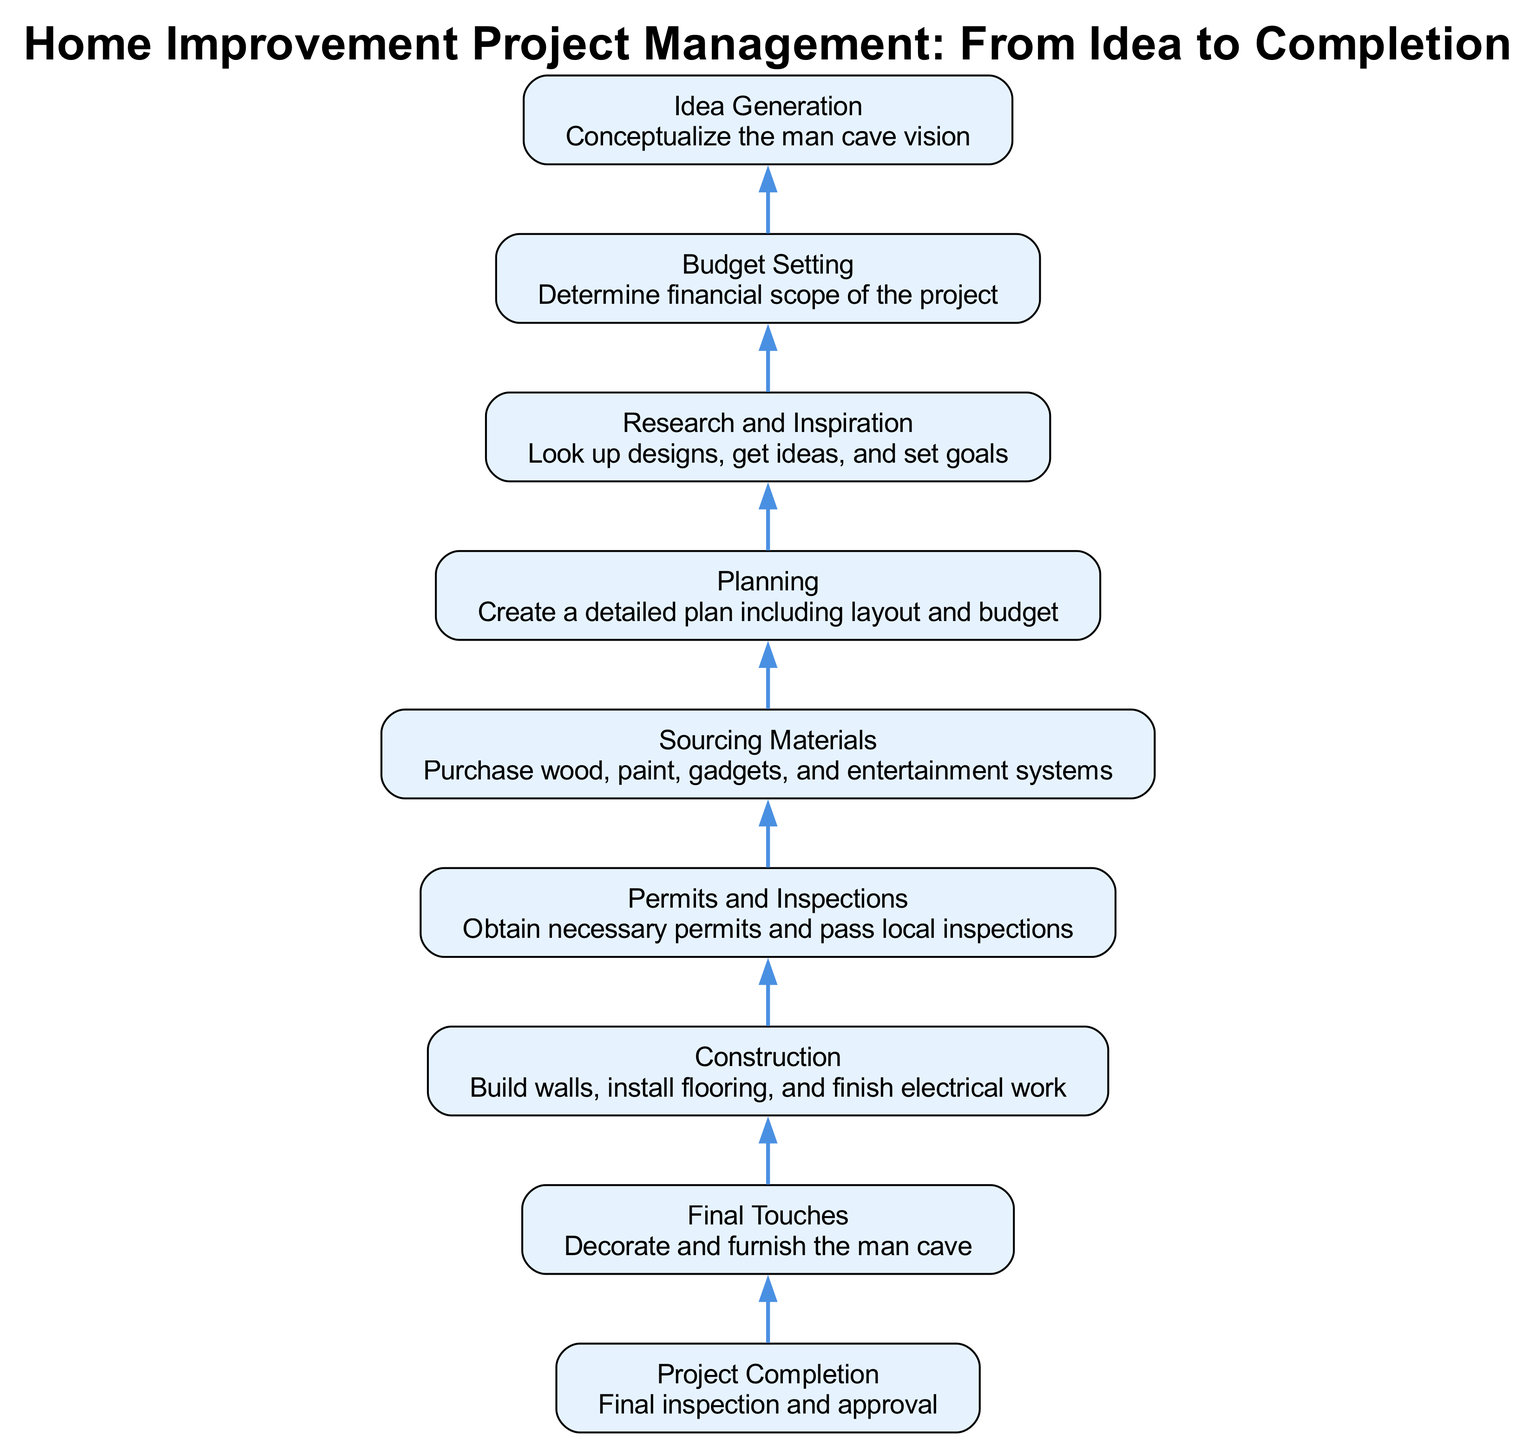What is the last step in the project? The last node in the flowchart is "Project Completion," which signifies the final inspection and approval needed to conclude the project. This node does not have any dependencies, indicating it is the end point.
Answer: Project Completion How many total steps are there in this flowchart? By counting each unique node in the flowchart, there are a total of 8 distinct steps listed before reaching "Project Completion."
Answer: 8 Which step comes directly before decorating and furnishing the man cave? The node labeled "Final Touches" comes after "Construction," indicating that "Construction" is the step directly prior to the final decoration phase.
Answer: Construction What is required before sourcing materials? The node "Permits and Inspections" must be completed before moving on to "Sourcing Materials," indicating that obtaining necessary permits is a prerequisite for purchasing items.
Answer: Permits and Inspections What is the initial stage in the flowchart? The first step listed is "Idea Generation," which is the starting point of the process where the concept for the man cave is created.
Answer: Idea Generation Which steps depend on the "Planning" phase? The steps that depend on the "Planning" phase are "Research and Inspiration" and subsequently "Budget Setting," which highlights the importance of planning in the overall project.
Answer: Research and Inspiration, Budget Setting What is the relationship between "Sourcing Materials" and "Construction"? "Sourcing Materials" follows after "Permits and Inspections," which indicates that "Construction" must occur prior to sourcing materials, establishing a sequential flow.
Answer: Construction must occur before sourcing materials How does the flowchart depict the project progression? The flowchart shows a top-to-bottom flow, indicating that each step in the process must be completed sequentially before moving onto the next stage, reflecting a structured approach to project management.
Answer: Top-to-bottom sequence 